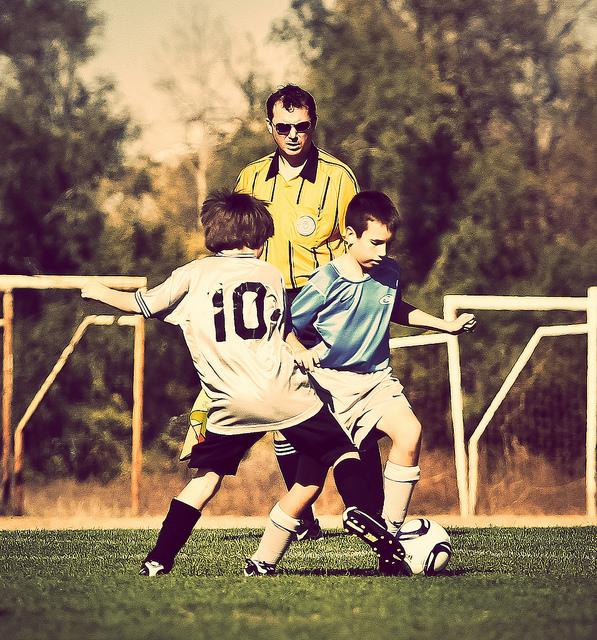What sort of job is the man standing in yellow doing? referee 